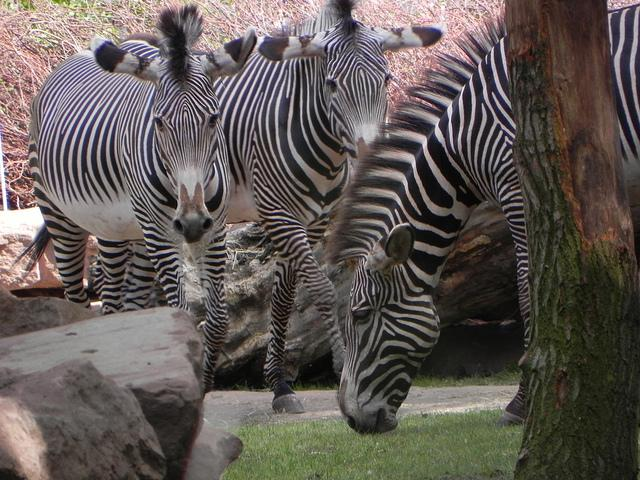What animals are most similar to these? Please explain your reasoning. horses. The zebras are similar in anatomy to horses. they have four legs and a mane. 